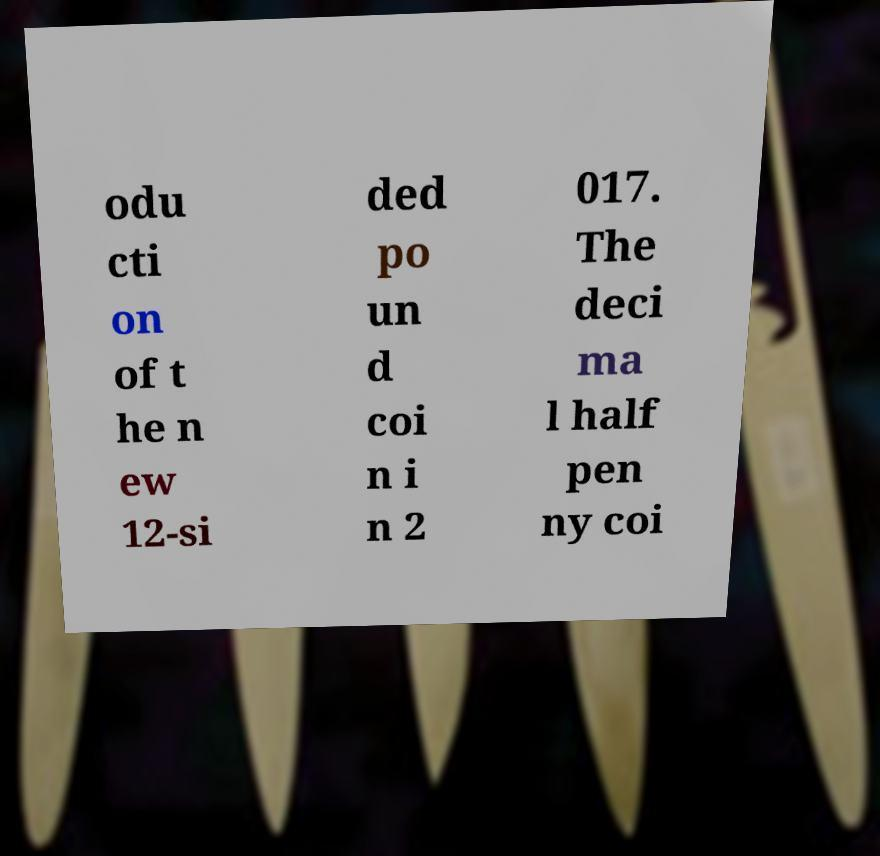Could you assist in decoding the text presented in this image and type it out clearly? odu cti on of t he n ew 12-si ded po un d coi n i n 2 017. The deci ma l half pen ny coi 